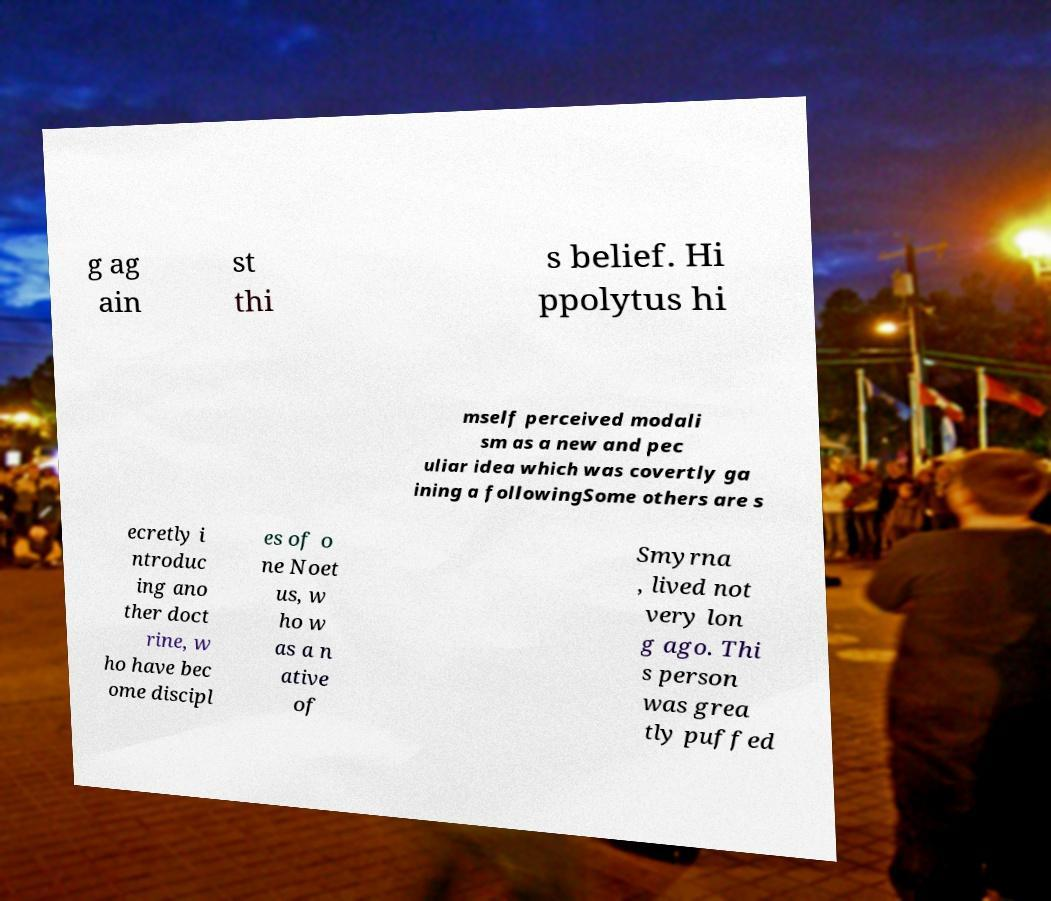Can you accurately transcribe the text from the provided image for me? g ag ain st thi s belief. Hi ppolytus hi mself perceived modali sm as a new and pec uliar idea which was covertly ga ining a followingSome others are s ecretly i ntroduc ing ano ther doct rine, w ho have bec ome discipl es of o ne Noet us, w ho w as a n ative of Smyrna , lived not very lon g ago. Thi s person was grea tly puffed 